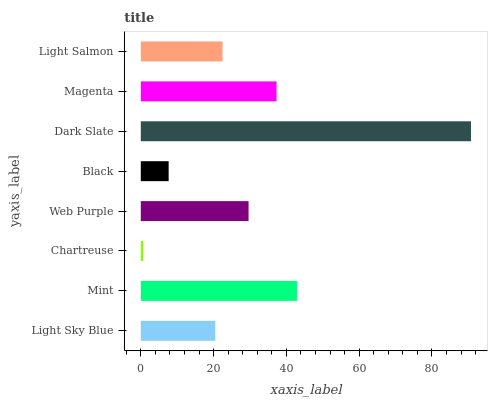Is Chartreuse the minimum?
Answer yes or no. Yes. Is Dark Slate the maximum?
Answer yes or no. Yes. Is Mint the minimum?
Answer yes or no. No. Is Mint the maximum?
Answer yes or no. No. Is Mint greater than Light Sky Blue?
Answer yes or no. Yes. Is Light Sky Blue less than Mint?
Answer yes or no. Yes. Is Light Sky Blue greater than Mint?
Answer yes or no. No. Is Mint less than Light Sky Blue?
Answer yes or no. No. Is Web Purple the high median?
Answer yes or no. Yes. Is Light Salmon the low median?
Answer yes or no. Yes. Is Black the high median?
Answer yes or no. No. Is Chartreuse the low median?
Answer yes or no. No. 